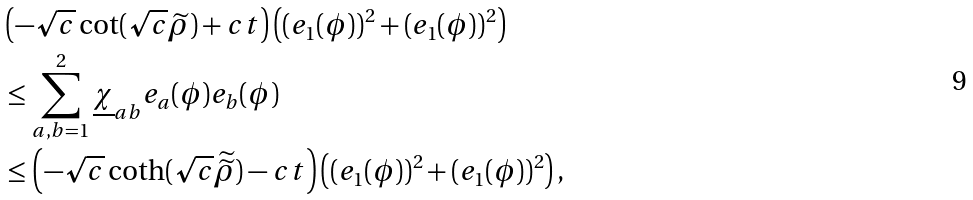Convert formula to latex. <formula><loc_0><loc_0><loc_500><loc_500>\\ & \left ( - \sqrt { c } \cot ( \sqrt { c } \widetilde { \rho } ) + c t \right ) \left ( ( e _ { 1 } ( \phi ) ) ^ { 2 } + ( e _ { 1 } ( \phi ) ) ^ { 2 } \right ) \\ & \leq \sum _ { a , b = 1 } ^ { 2 } \underline { \chi } _ { a b } e _ { a } ( \phi ) e _ { b } ( \phi ) \\ & \leq \left ( - \sqrt { c } \coth ( \sqrt { c } \widetilde { \widetilde { \rho } } ) - c t \right ) \left ( ( e _ { 1 } ( \phi ) ) ^ { 2 } + ( e _ { 1 } ( \phi ) ) ^ { 2 } \right ) , \\</formula> 